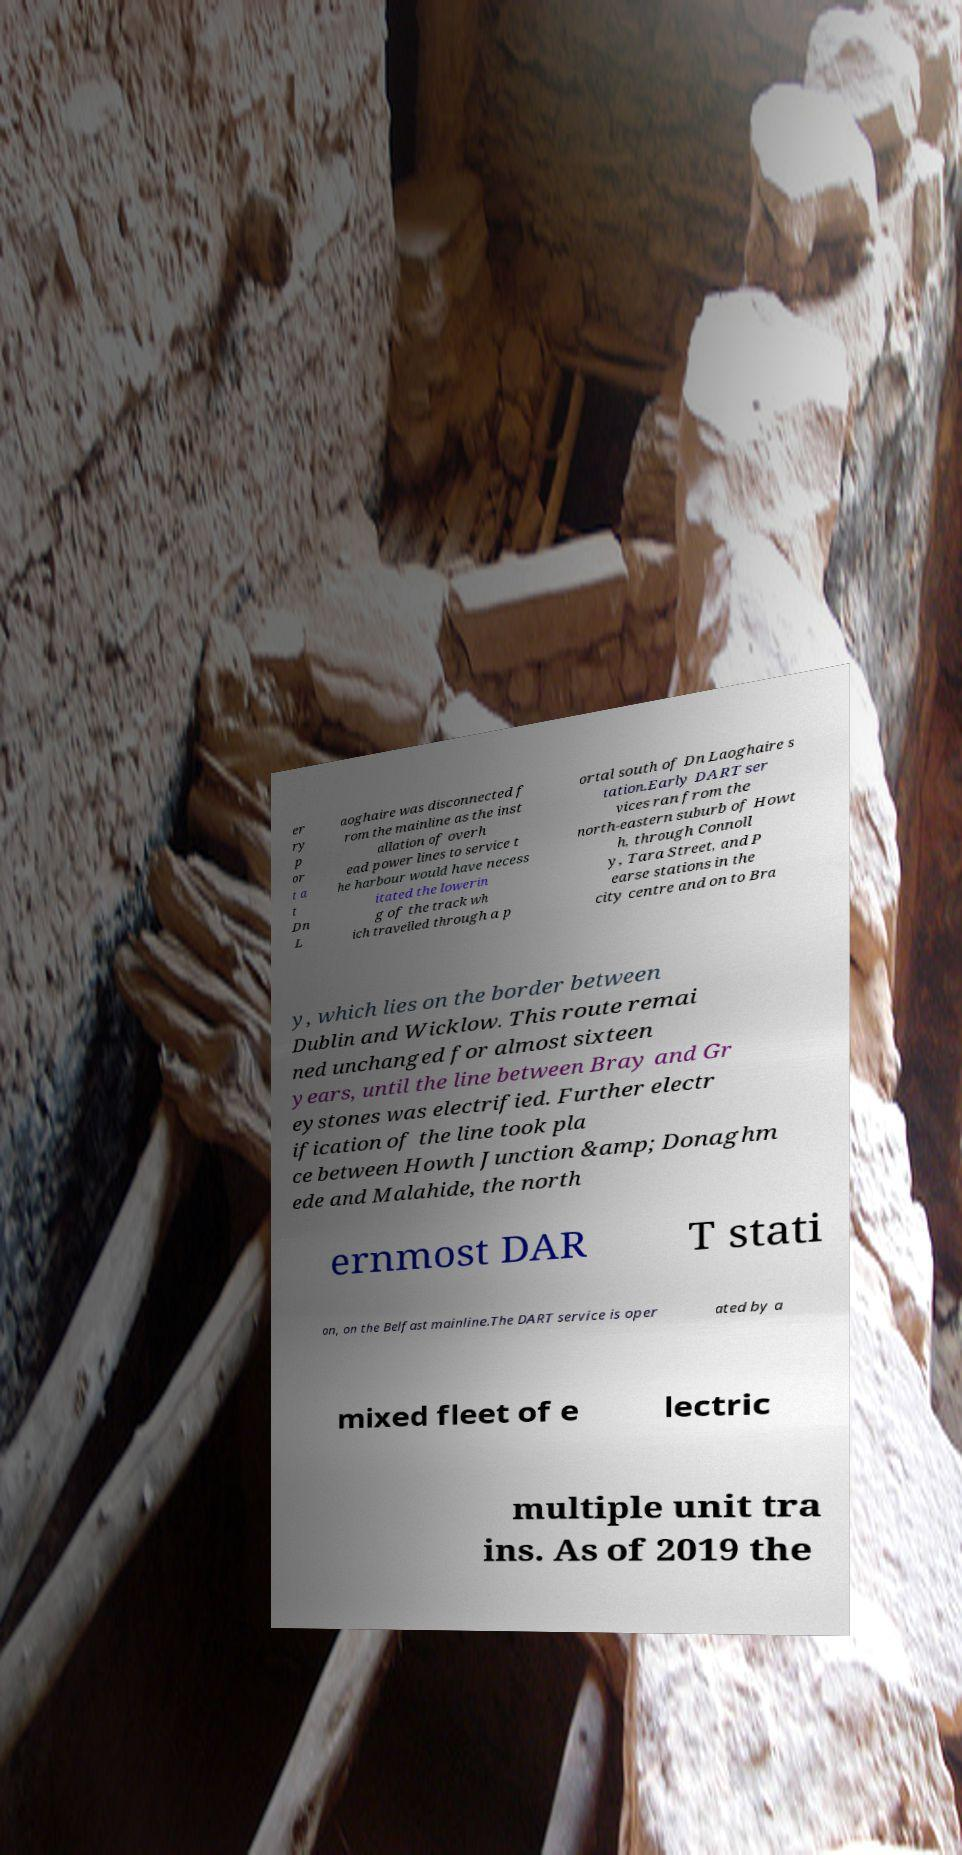For documentation purposes, I need the text within this image transcribed. Could you provide that? er ry p or t a t Dn L aoghaire was disconnected f rom the mainline as the inst allation of overh ead power lines to service t he harbour would have necess itated the lowerin g of the track wh ich travelled through a p ortal south of Dn Laoghaire s tation.Early DART ser vices ran from the north-eastern suburb of Howt h, through Connoll y, Tara Street, and P earse stations in the city centre and on to Bra y, which lies on the border between Dublin and Wicklow. This route remai ned unchanged for almost sixteen years, until the line between Bray and Gr eystones was electrified. Further electr ification of the line took pla ce between Howth Junction &amp; Donaghm ede and Malahide, the north ernmost DAR T stati on, on the Belfast mainline.The DART service is oper ated by a mixed fleet of e lectric multiple unit tra ins. As of 2019 the 